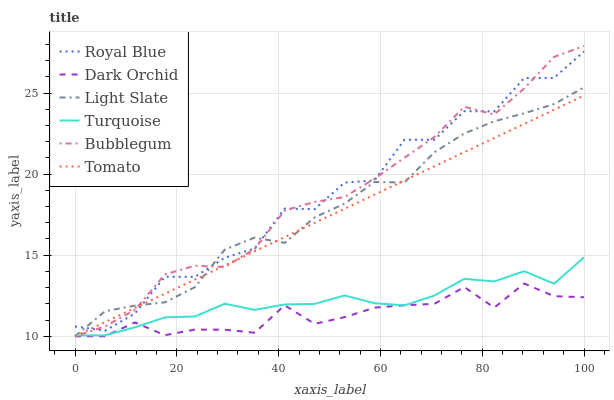Does Dark Orchid have the minimum area under the curve?
Answer yes or no. Yes. Does Royal Blue have the maximum area under the curve?
Answer yes or no. Yes. Does Turquoise have the minimum area under the curve?
Answer yes or no. No. Does Turquoise have the maximum area under the curve?
Answer yes or no. No. Is Tomato the smoothest?
Answer yes or no. Yes. Is Royal Blue the roughest?
Answer yes or no. Yes. Is Turquoise the smoothest?
Answer yes or no. No. Is Turquoise the roughest?
Answer yes or no. No. Does Tomato have the lowest value?
Answer yes or no. Yes. Does Turquoise have the lowest value?
Answer yes or no. No. Does Bubblegum have the highest value?
Answer yes or no. Yes. Does Turquoise have the highest value?
Answer yes or no. No. Is Dark Orchid less than Royal Blue?
Answer yes or no. Yes. Is Royal Blue greater than Dark Orchid?
Answer yes or no. Yes. Does Turquoise intersect Dark Orchid?
Answer yes or no. Yes. Is Turquoise less than Dark Orchid?
Answer yes or no. No. Is Turquoise greater than Dark Orchid?
Answer yes or no. No. Does Dark Orchid intersect Royal Blue?
Answer yes or no. No. 